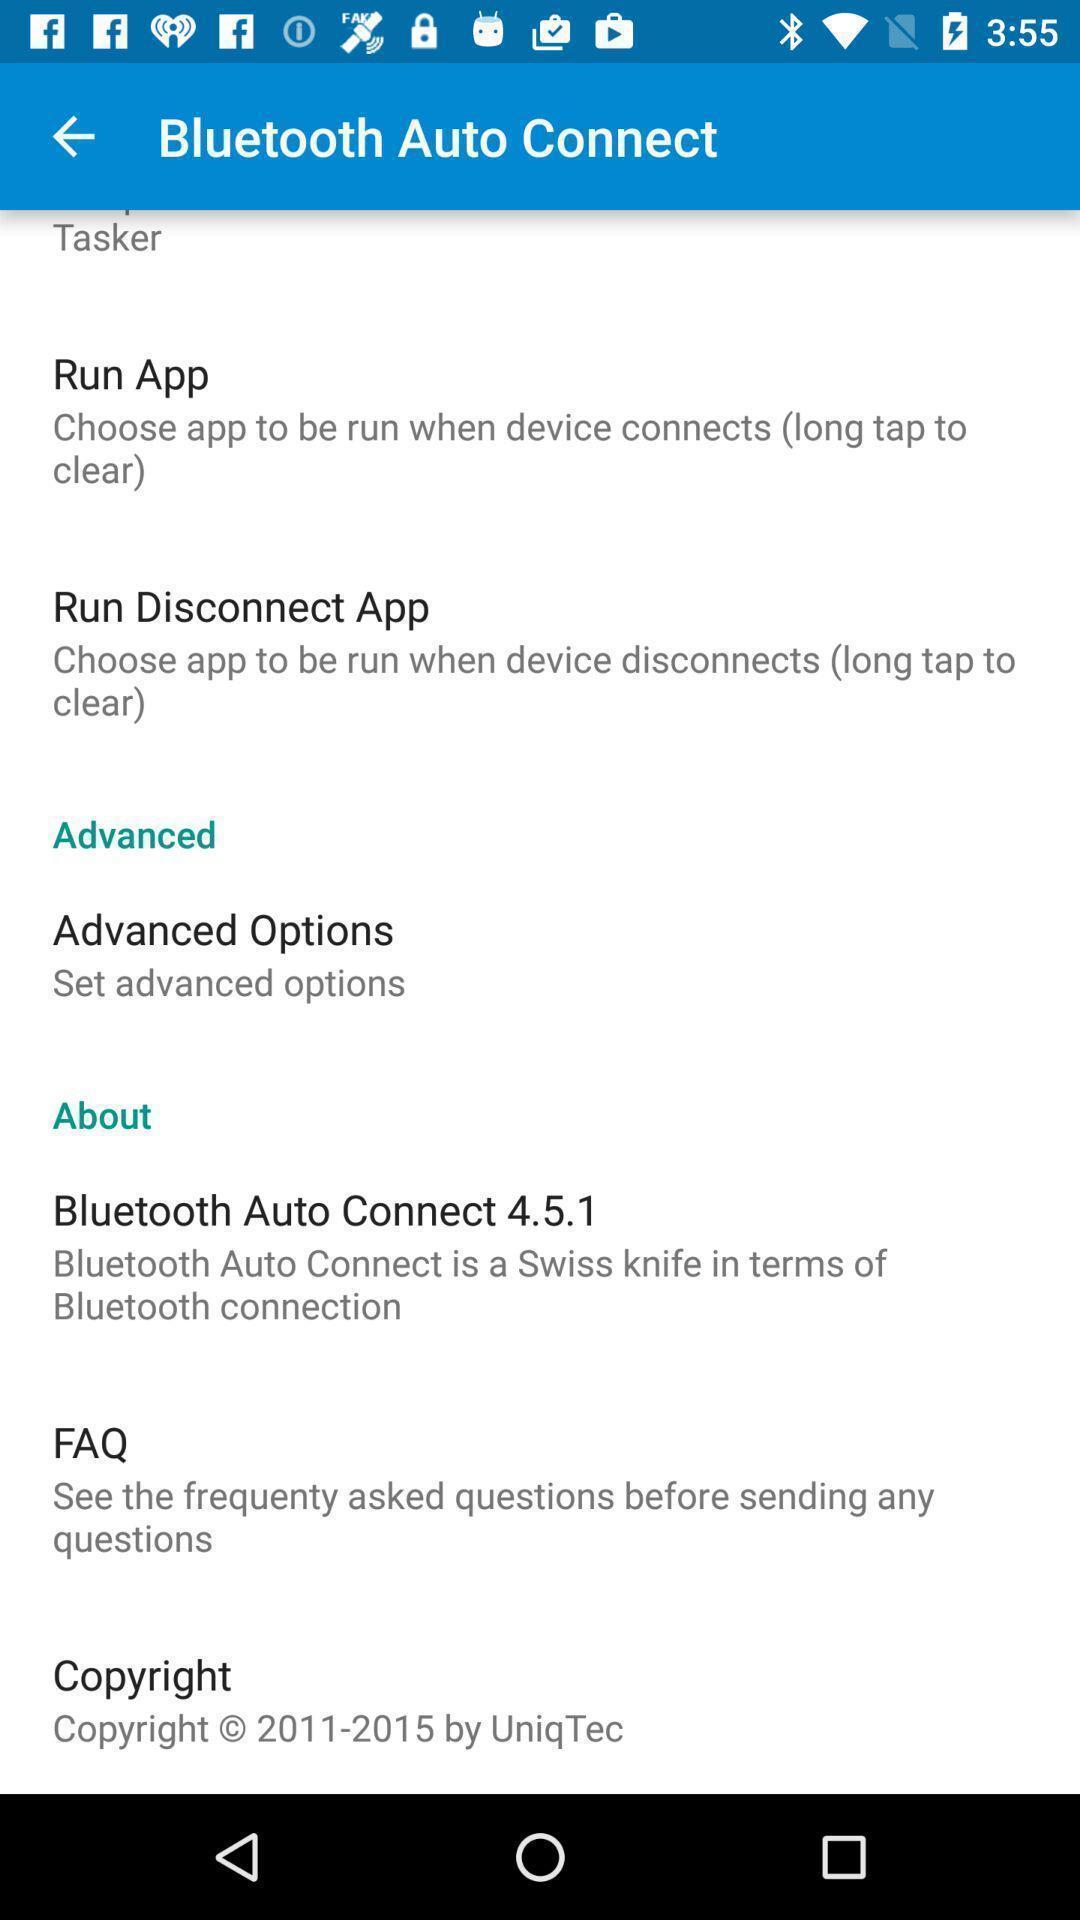Give me a summary of this screen capture. Page showing different options to connect bluetooth. 